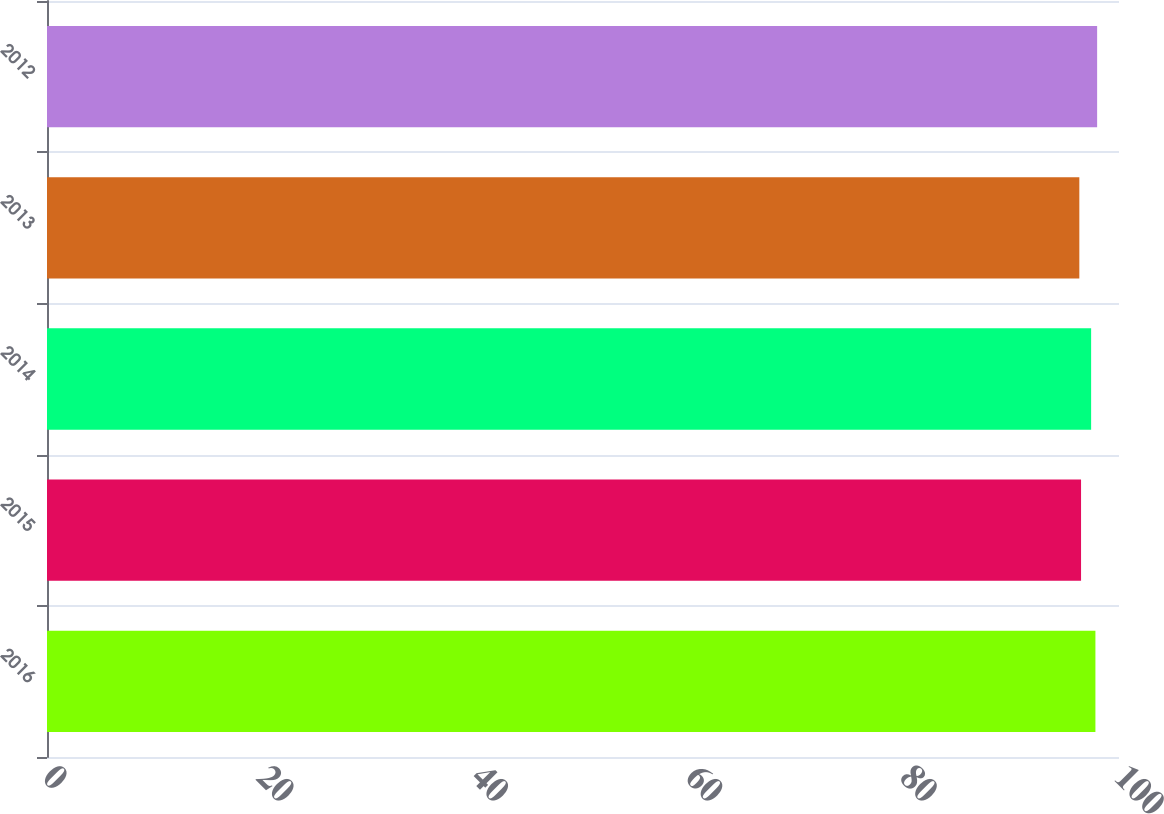Convert chart. <chart><loc_0><loc_0><loc_500><loc_500><bar_chart><fcel>2016<fcel>2015<fcel>2014<fcel>2013<fcel>2012<nl><fcel>97.8<fcel>96.46<fcel>97.4<fcel>96.3<fcel>97.96<nl></chart> 